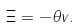<formula> <loc_0><loc_0><loc_500><loc_500>\Xi = - \theta v .</formula> 